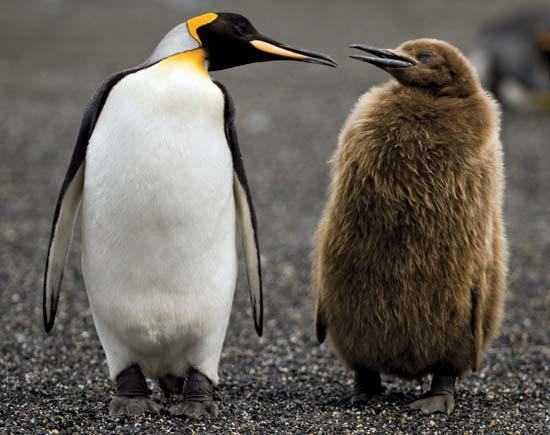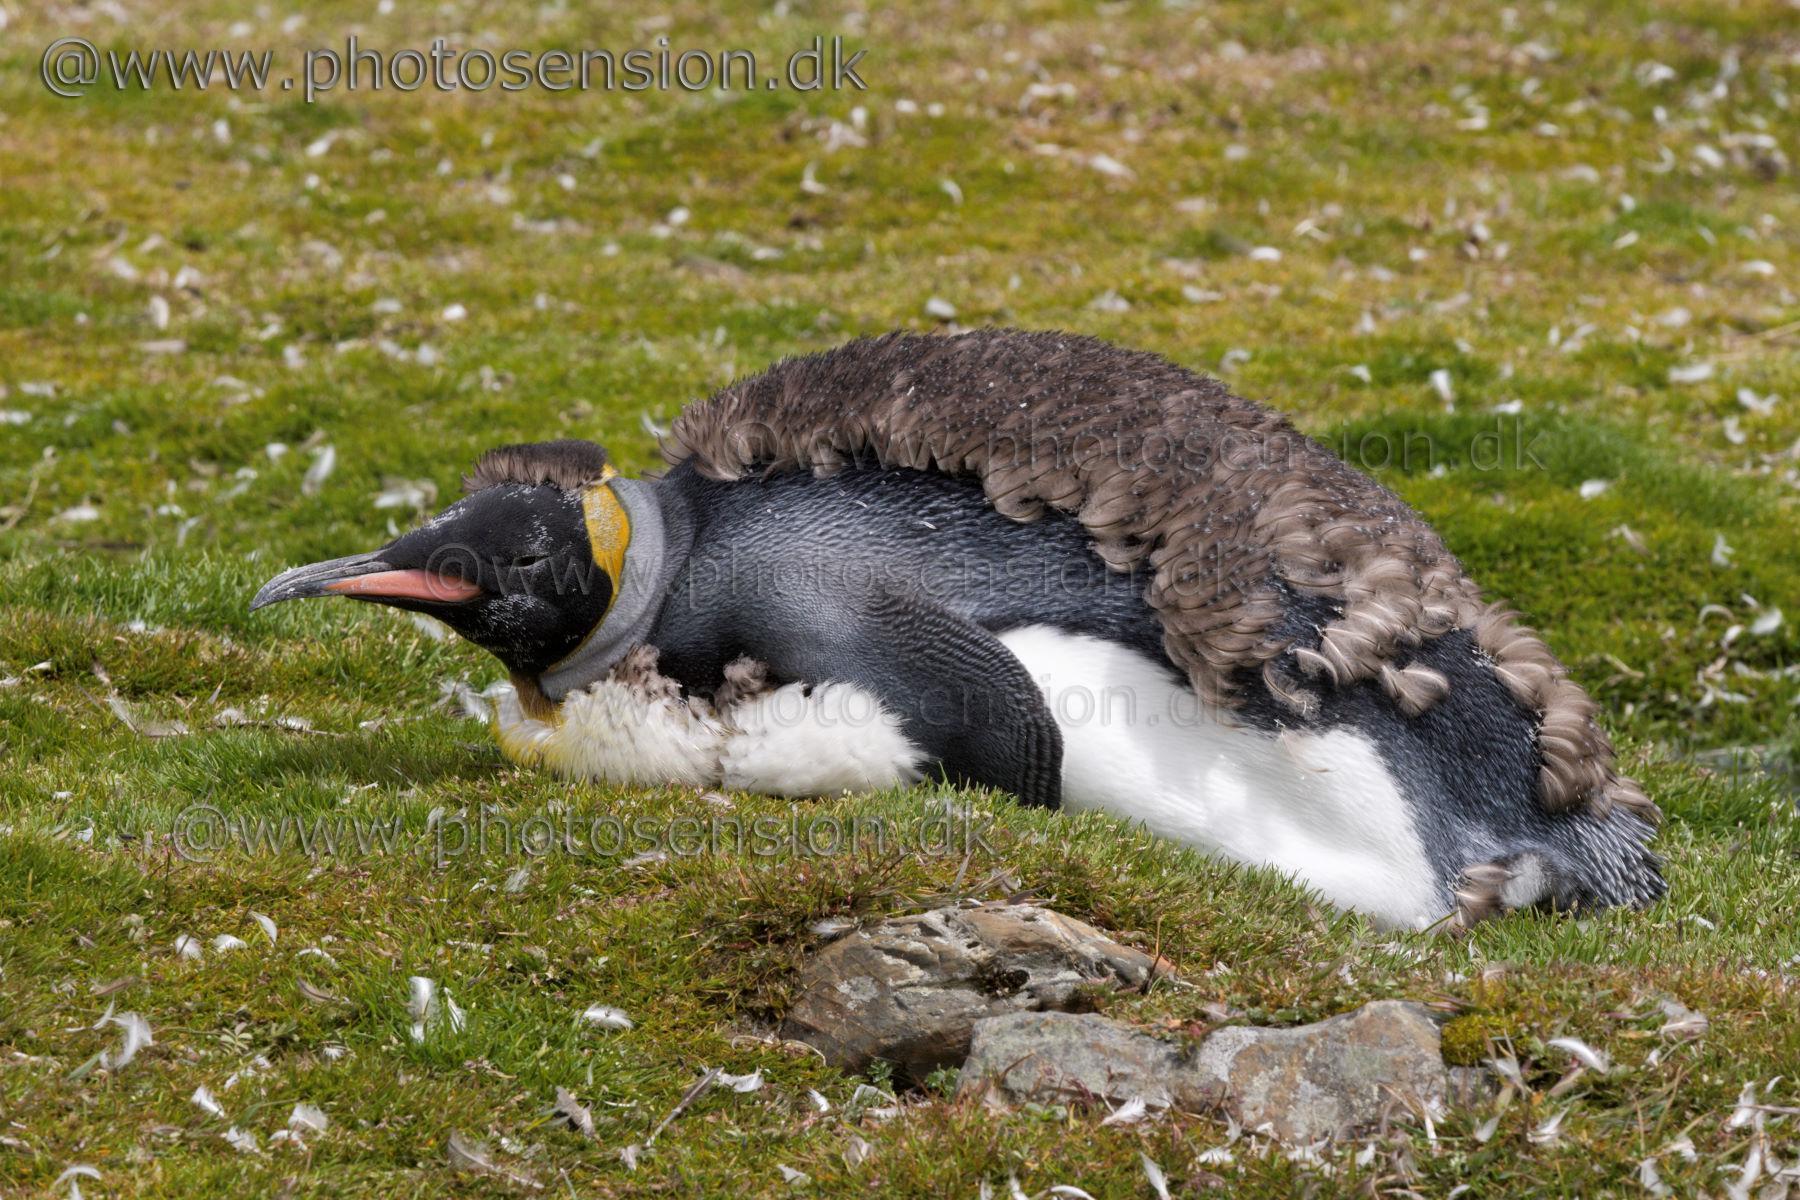The first image is the image on the left, the second image is the image on the right. Considering the images on both sides, is "Two penguins stand together in the image on the right." valid? Answer yes or no. No. 